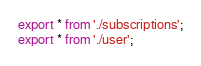<code> <loc_0><loc_0><loc_500><loc_500><_JavaScript_>export * from './subscriptions';
export * from './user';
</code> 